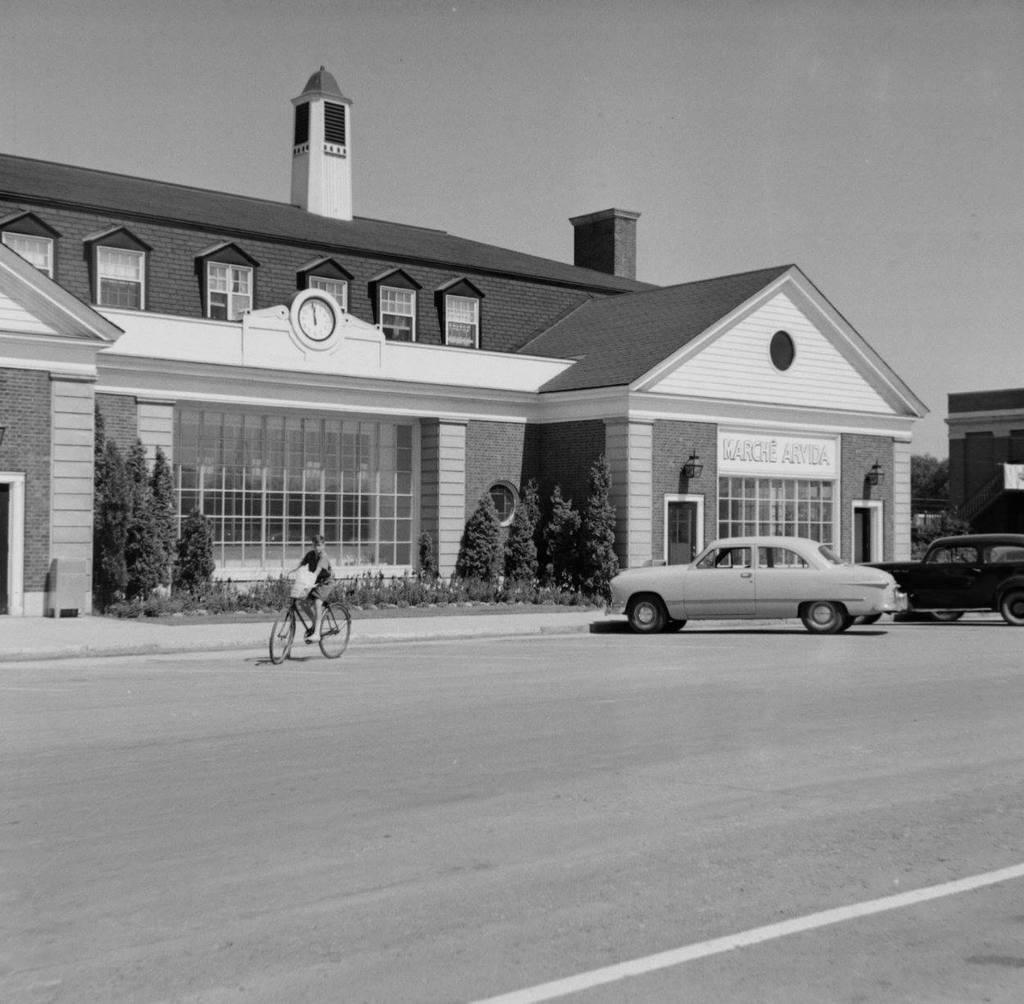Can you describe this image briefly? This picture is clicked outside. In the foreground we can see the cars parked on the road and we can see a person riding a bicycle and we can see the plants, trees and the grass. In the center we can see the buildings and we can see the text on the building and a clock hanging on the wall of the building and we can see the lamps attached to the wall. In the background we can see the sky and the trees. 